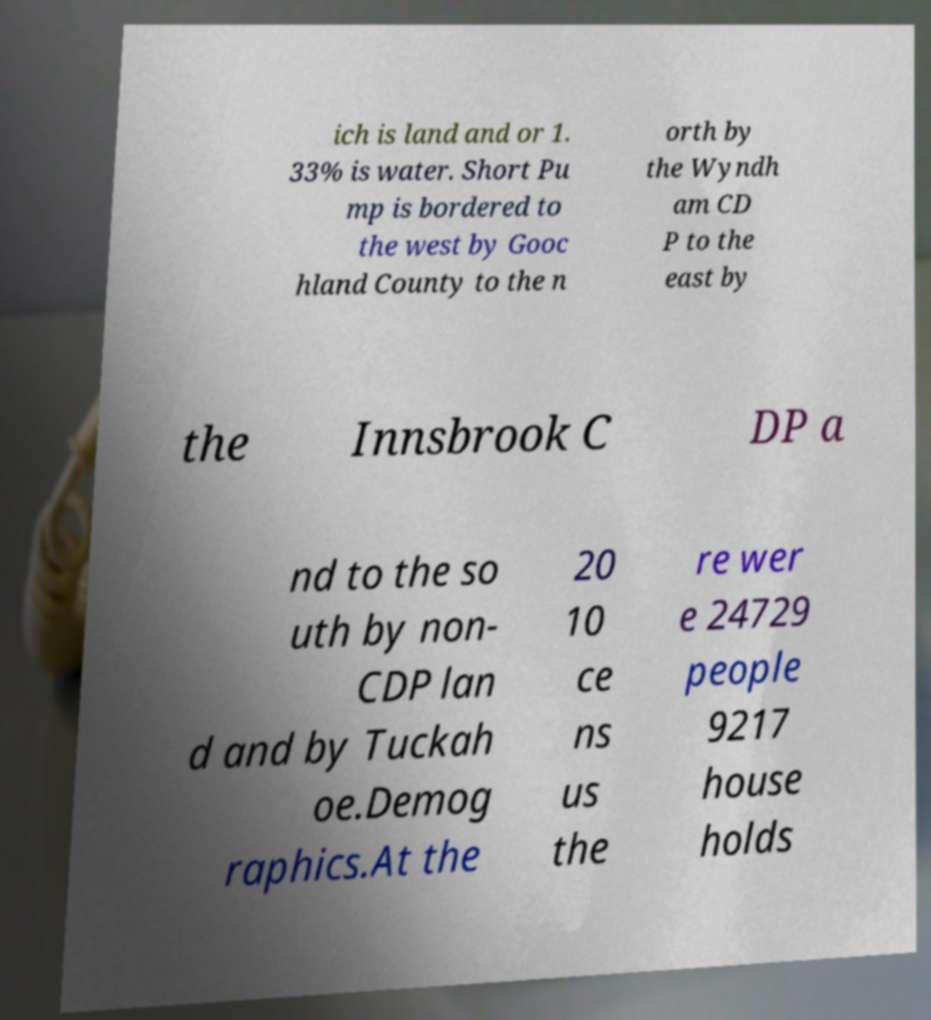What messages or text are displayed in this image? I need them in a readable, typed format. ich is land and or 1. 33% is water. Short Pu mp is bordered to the west by Gooc hland County to the n orth by the Wyndh am CD P to the east by the Innsbrook C DP a nd to the so uth by non- CDP lan d and by Tuckah oe.Demog raphics.At the 20 10 ce ns us the re wer e 24729 people 9217 house holds 